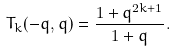<formula> <loc_0><loc_0><loc_500><loc_500>T _ { k } ( - q , q ) = \frac { 1 + q ^ { 2 k + 1 } } { 1 + q } .</formula> 